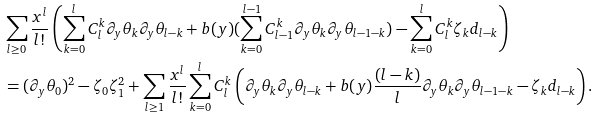<formula> <loc_0><loc_0><loc_500><loc_500>& \sum _ { l \geq 0 } \frac { x ^ { l } } { l ! } \left ( \sum _ { k = 0 } ^ { l } C _ { l } ^ { k } \partial _ { y } \theta _ { k } \partial _ { y } \theta _ { l - k } + b ( y ) ( \sum _ { k = 0 } ^ { l - 1 } C _ { l - 1 } ^ { k } \partial _ { y } \theta _ { k } \partial _ { y } \theta _ { l - 1 - k } ) - \sum _ { k = 0 } ^ { l } C _ { l } ^ { k } \zeta _ { k } d _ { l - k } \right ) \\ & = ( \partial _ { y } \theta _ { 0 } ) ^ { 2 } - \zeta _ { 0 } \zeta _ { 1 } ^ { 2 } + \sum _ { l \geq 1 } \frac { x ^ { l } } { l ! } \sum _ { k = 0 } ^ { l } C _ { l } ^ { k } \left ( \partial _ { y } \theta _ { k } \partial _ { y } \theta _ { l - k } + b ( y ) \frac { ( l - k ) } { l } \partial _ { y } \theta _ { k } \partial _ { y } \theta _ { l - 1 - k } - \zeta _ { k } d _ { l - k } \right ) .</formula> 